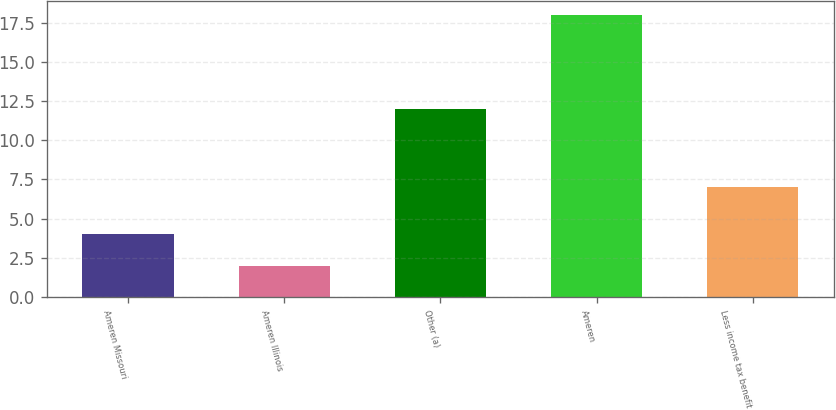<chart> <loc_0><loc_0><loc_500><loc_500><bar_chart><fcel>Ameren Missouri<fcel>Ameren Illinois<fcel>Other (a)<fcel>Ameren<fcel>Less income tax benefit<nl><fcel>4<fcel>2<fcel>12<fcel>18<fcel>7<nl></chart> 